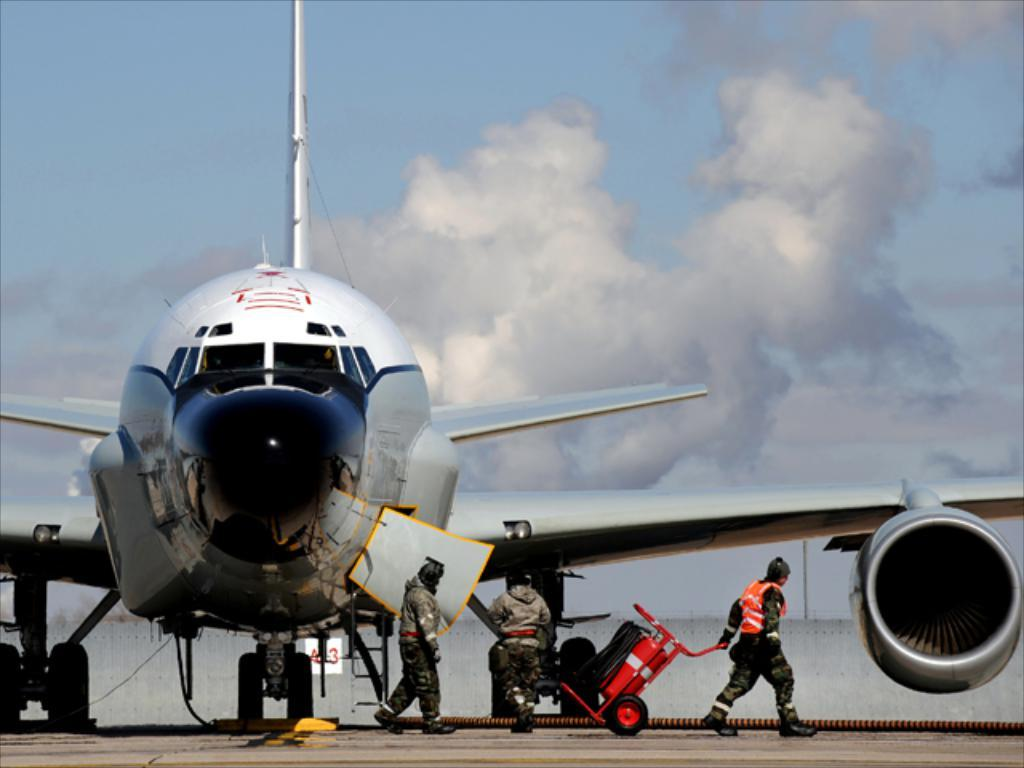What can be seen in the foreground of the image? There are people and an aircraft in the foreground of the image. What is visible in the background of the image? The sky is visible in the background of the image. What type of music is being played by the aircraft in the image? There is no indication in the image that the aircraft is playing music, so it cannot be determined from the picture. 